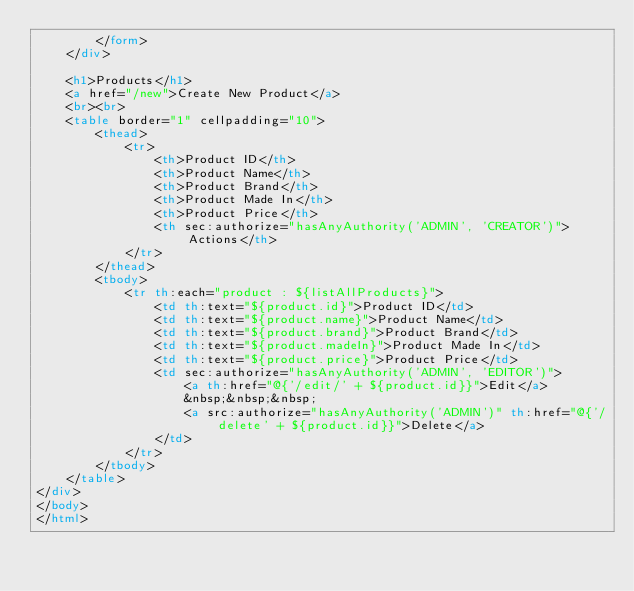Convert code to text. <code><loc_0><loc_0><loc_500><loc_500><_HTML_>        </form>
    </div>

    <h1>Products</h1>
    <a href="/new">Create New Product</a>
    <br><br>
    <table border="1" cellpadding="10">
        <thead>
            <tr>
                <th>Product ID</th>
                <th>Product Name</th>
                <th>Product Brand</th>
                <th>Product Made In</th>
                <th>Product Price</th>
                <th sec:authorize="hasAnyAuthority('ADMIN', 'CREATOR')">Actions</th>
            </tr>
        </thead>
        <tbody>
            <tr th:each="product : ${listAllProducts}">
                <td th:text="${product.id}">Product ID</td>
                <td th:text="${product.name}">Product Name</td>
                <td th:text="${product.brand}">Product Brand</td>
                <td th:text="${product.madeIn}">Product Made In</td>
                <td th:text="${product.price}">Product Price</td>
                <td sec:authorize="hasAnyAuthority('ADMIN', 'EDITOR')">
                    <a th:href="@{'/edit/' + ${product.id}}">Edit</a>
                    &nbsp;&nbsp;&nbsp;
                    <a src:authorize="hasAnyAuthority('ADMIN')" th:href="@{'/delete' + ${product.id}}">Delete</a>
                </td>
            </tr>
        </tbody>
    </table>
</div>
</body>
</html></code> 